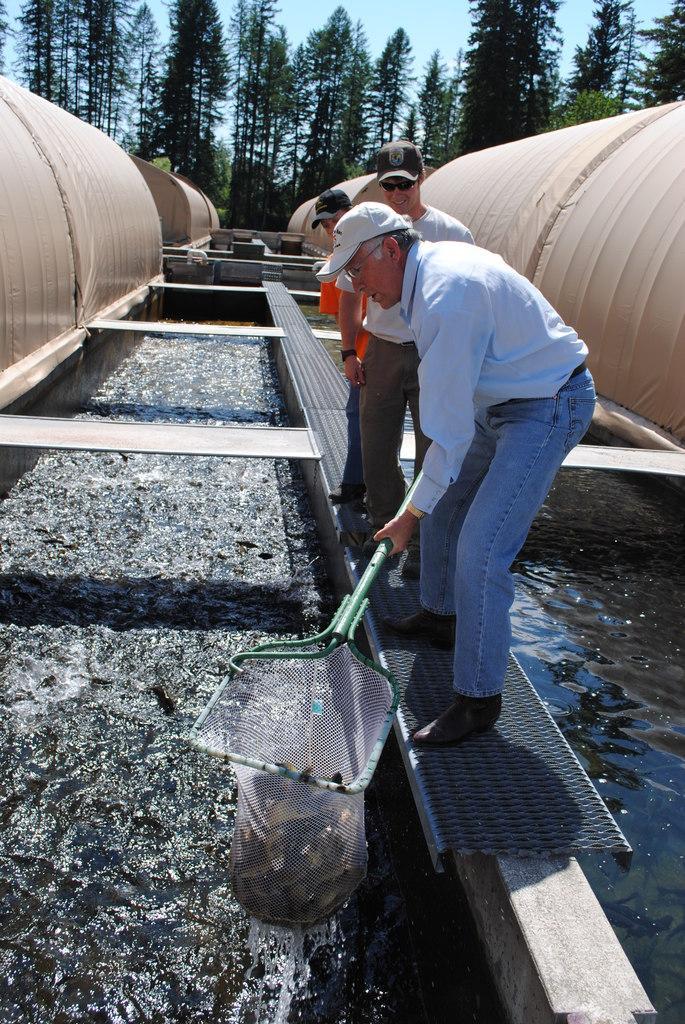Please provide a concise description of this image. In this image there is a fish pond, there are three man standing near the fish pond and a man is catching fishes with net, in the background there are trees. 